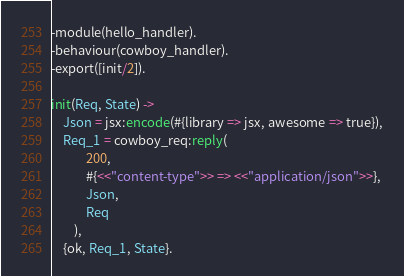<code> <loc_0><loc_0><loc_500><loc_500><_Erlang_>-module(hello_handler).
-behaviour(cowboy_handler).
-export([init/2]).

init(Req, State) ->
	Json = jsx:encode(#{library => jsx, awesome => true}),
	Req_1 = cowboy_req:reply(
			200,
			#{<<"content-type">> => <<"application/json">>},
			Json,
			Req
		),
	{ok, Req_1, State}.
</code> 